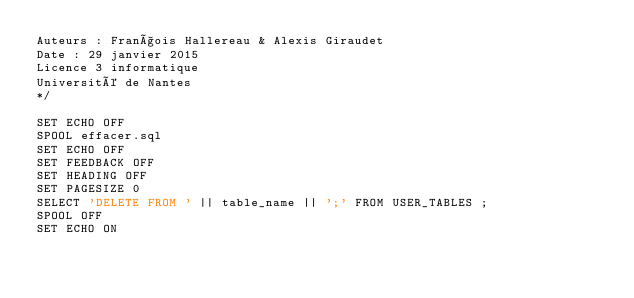<code> <loc_0><loc_0><loc_500><loc_500><_SQL_>Auteurs : François Hallereau & Alexis Giraudet
Date : 29 janvier 2015
Licence 3 informatique
Université de Nantes
*/

SET ECHO OFF
SPOOL effacer.sql
SET ECHO OFF
SET FEEDBACK OFF
SET HEADING OFF
SET PAGESIZE 0
SELECT 'DELETE FROM ' || table_name || ';' FROM USER_TABLES ;
SPOOL OFF
SET ECHO ON
</code> 